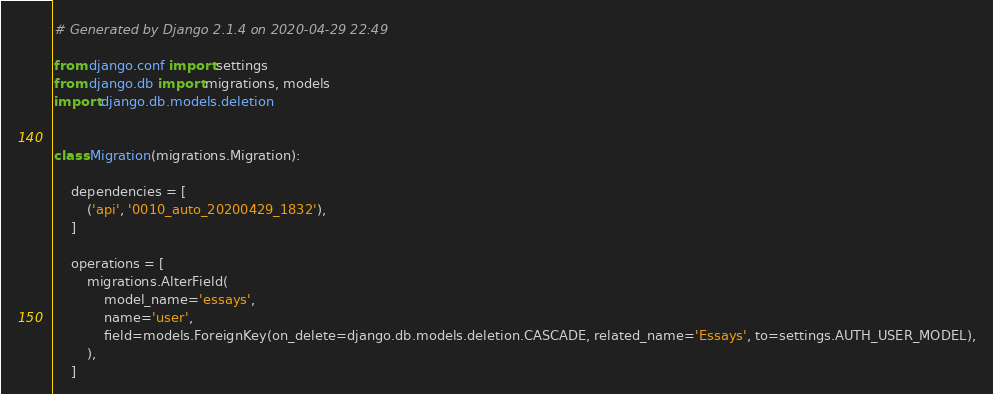Convert code to text. <code><loc_0><loc_0><loc_500><loc_500><_Python_># Generated by Django 2.1.4 on 2020-04-29 22:49

from django.conf import settings
from django.db import migrations, models
import django.db.models.deletion


class Migration(migrations.Migration):

    dependencies = [
        ('api', '0010_auto_20200429_1832'),
    ]

    operations = [
        migrations.AlterField(
            model_name='essays',
            name='user',
            field=models.ForeignKey(on_delete=django.db.models.deletion.CASCADE, related_name='Essays', to=settings.AUTH_USER_MODEL),
        ),
    ]
</code> 